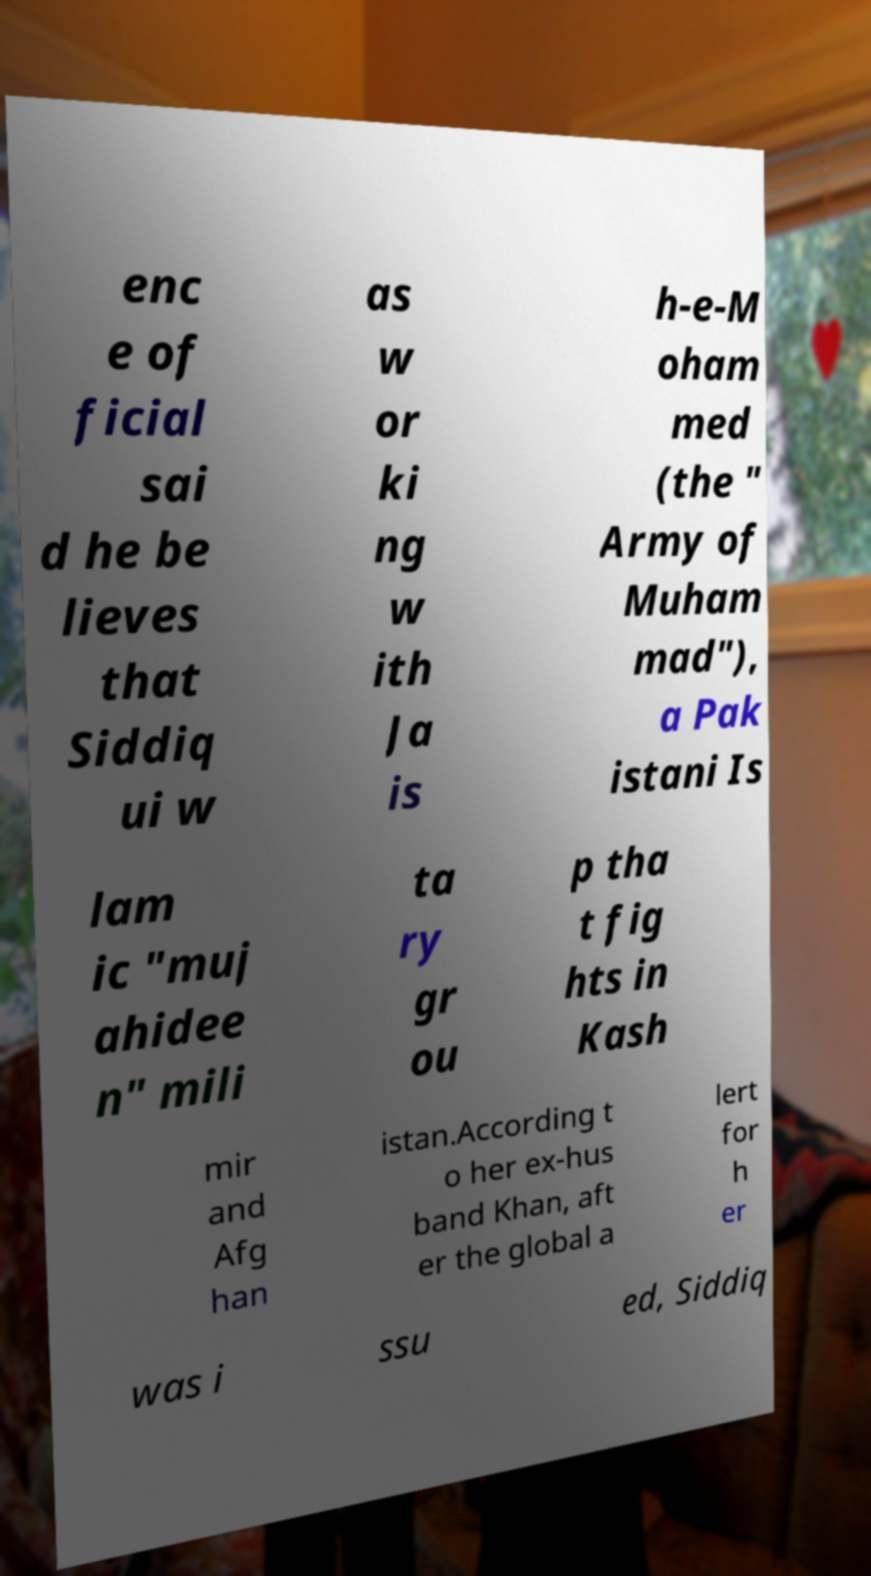I need the written content from this picture converted into text. Can you do that? enc e of ficial sai d he be lieves that Siddiq ui w as w or ki ng w ith Ja is h-e-M oham med (the " Army of Muham mad"), a Pak istani Is lam ic "muj ahidee n" mili ta ry gr ou p tha t fig hts in Kash mir and Afg han istan.According t o her ex-hus band Khan, aft er the global a lert for h er was i ssu ed, Siddiq 